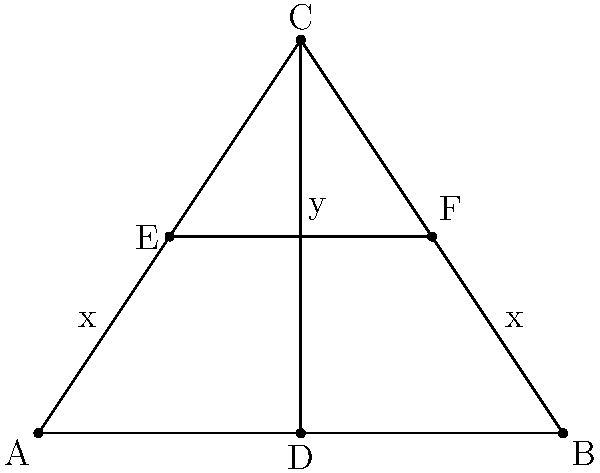In the given triangle ABC with median CD and line segment EF parallel to AB, if AE = BF = x and CD = y, what is the ratio of x to y? Let's approach this step-by-step:

1) In a triangle, a median divides the opposite side into two equal parts. So, AD = DB.

2) EF is parallel to AB, and AE = BF = x. This means that E and F are the midpoints of AC and BC respectively.

3) In a triangle, a line segment connecting the midpoints of two sides is parallel to the third side and half the length of the third side. So, EF = 1/2 AB.

4) Since E and F are midpoints, AE = 1/2 AC and BF = 1/2 BC.

5) In any triangle, the median to a side is 2/3 the length of a parallel line segment that has its endpoints on the other two sides and is parallel to the side to which the median is drawn.

6) Therefore, CD = 2/3 EF.

7) We know that EF = 1/2 AB and x = 1/2 AC = 1/2 BC.

8) Let's say AB = 2a. Then EF = a and x = a/2.

9) Since CD = 2/3 EF, y = 2/3 a.

10) Now we can set up the ratio: x : y = (a/2) : (2a/3) = 3 : 4

Therefore, the ratio of x to y is 3:4.
Answer: 3:4 